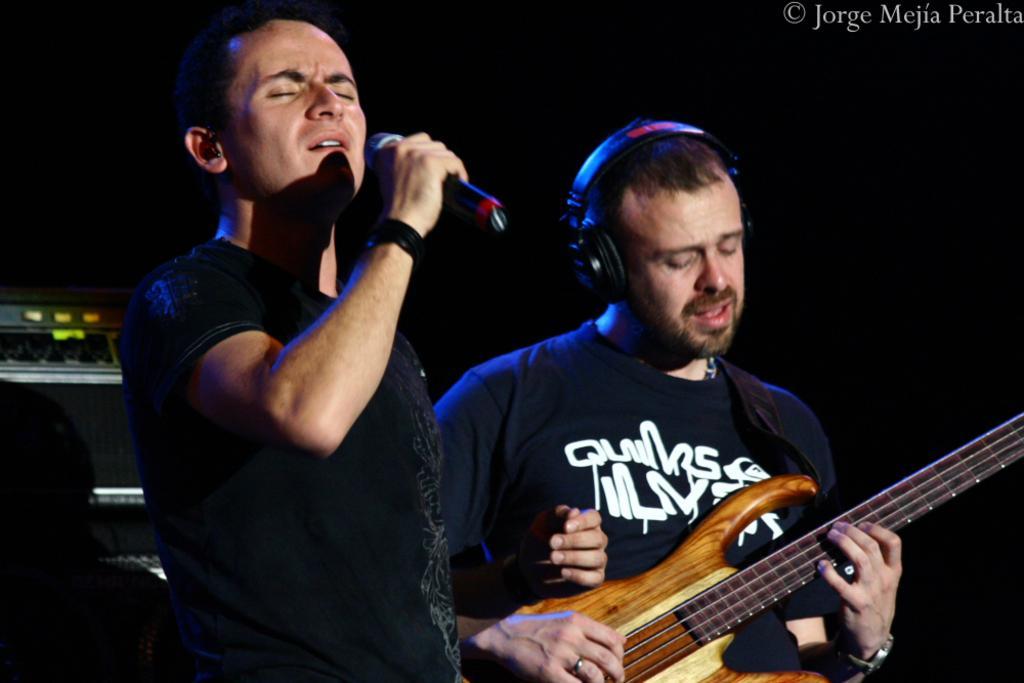Describe this image in one or two sentences. In this picture we can see two persons were on left side person singing on mic and on right side person holding guitar with hand and playing it with headphones to him. 